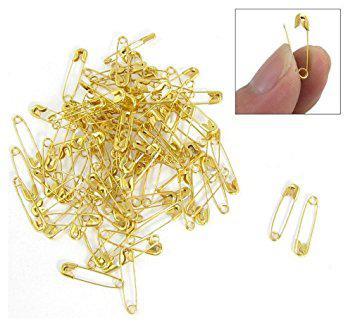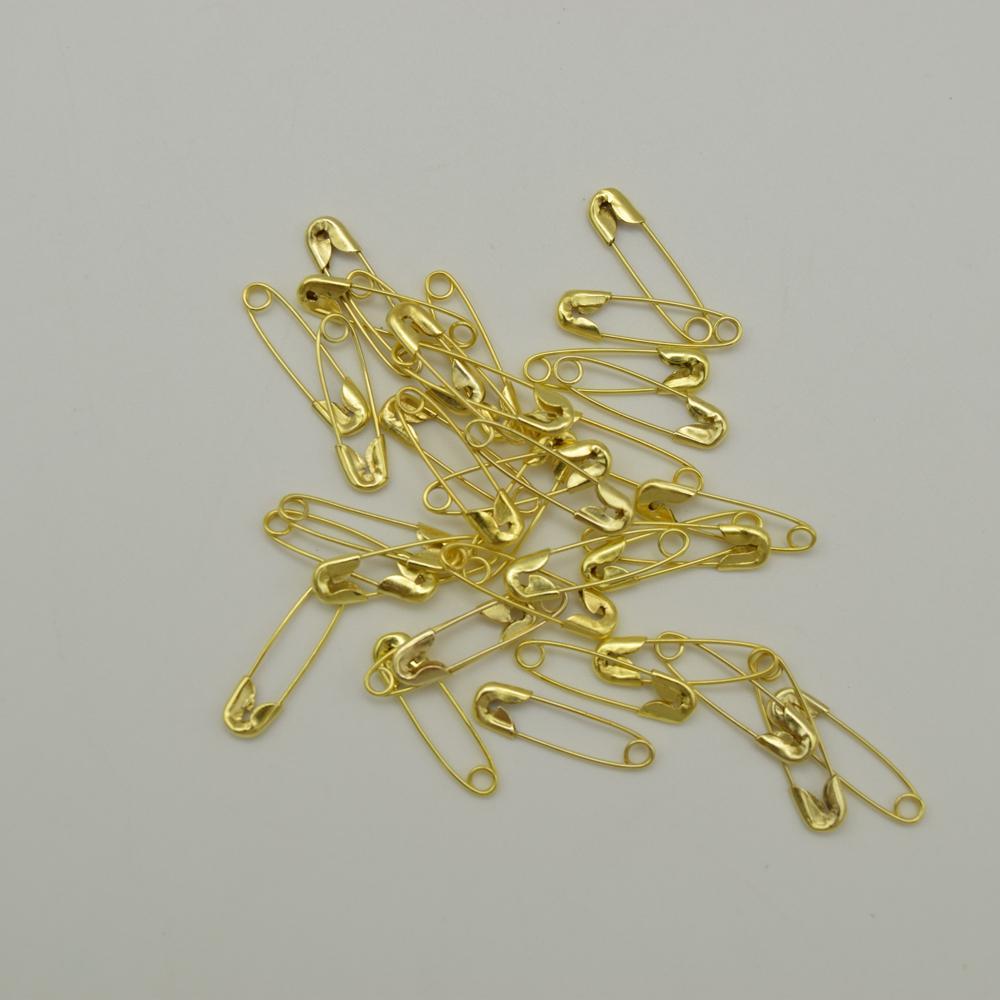The first image is the image on the left, the second image is the image on the right. Assess this claim about the two images: "Both images contain safety pins.". Correct or not? Answer yes or no. Yes. 